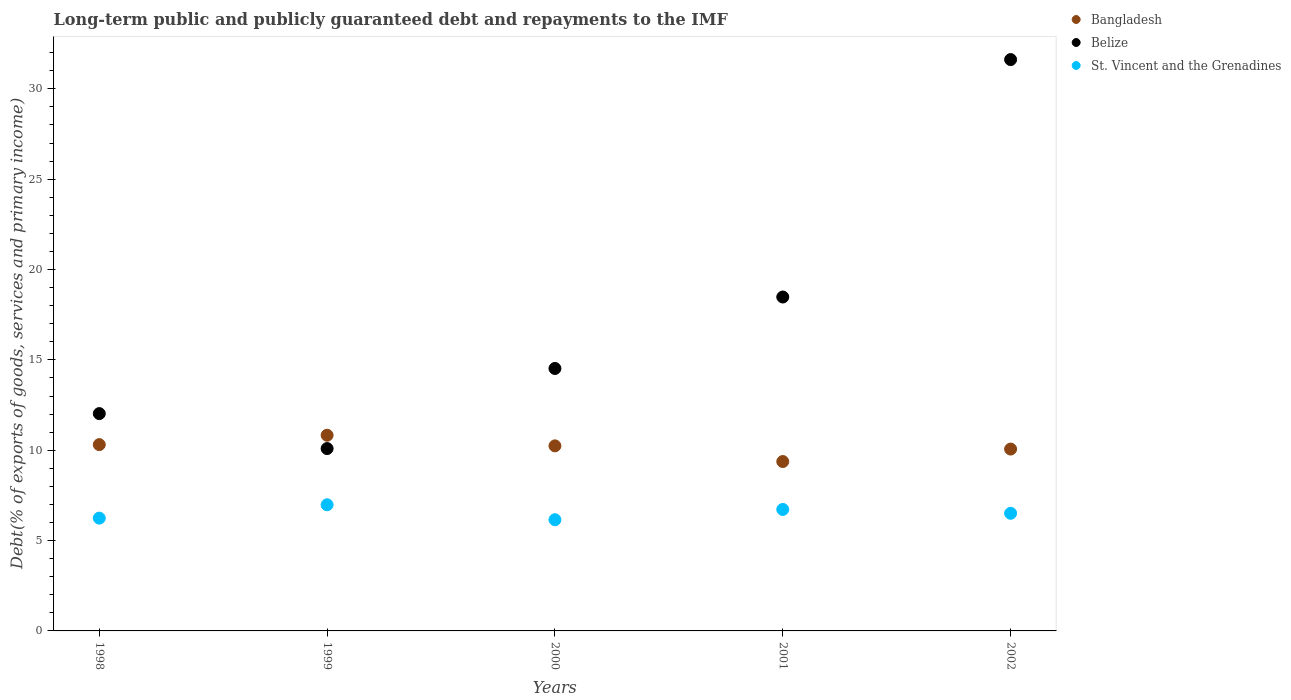Is the number of dotlines equal to the number of legend labels?
Offer a very short reply. Yes. What is the debt and repayments in Belize in 2001?
Provide a succinct answer. 18.48. Across all years, what is the maximum debt and repayments in Bangladesh?
Make the answer very short. 10.83. Across all years, what is the minimum debt and repayments in Belize?
Keep it short and to the point. 10.09. In which year was the debt and repayments in St. Vincent and the Grenadines maximum?
Keep it short and to the point. 1999. What is the total debt and repayments in Belize in the graph?
Offer a very short reply. 86.74. What is the difference between the debt and repayments in St. Vincent and the Grenadines in 1998 and that in 2001?
Offer a very short reply. -0.48. What is the difference between the debt and repayments in Belize in 1998 and the debt and repayments in St. Vincent and the Grenadines in 2000?
Offer a terse response. 5.87. What is the average debt and repayments in Bangladesh per year?
Provide a succinct answer. 10.16. In the year 2002, what is the difference between the debt and repayments in Belize and debt and repayments in Bangladesh?
Provide a succinct answer. 21.56. In how many years, is the debt and repayments in Bangladesh greater than 23 %?
Offer a very short reply. 0. What is the ratio of the debt and repayments in Bangladesh in 1998 to that in 1999?
Your response must be concise. 0.95. Is the debt and repayments in St. Vincent and the Grenadines in 1998 less than that in 1999?
Provide a succinct answer. Yes. Is the difference between the debt and repayments in Belize in 2000 and 2002 greater than the difference between the debt and repayments in Bangladesh in 2000 and 2002?
Offer a very short reply. No. What is the difference between the highest and the second highest debt and repayments in Belize?
Provide a short and direct response. 13.14. What is the difference between the highest and the lowest debt and repayments in Bangladesh?
Make the answer very short. 1.46. Is it the case that in every year, the sum of the debt and repayments in Belize and debt and repayments in St. Vincent and the Grenadines  is greater than the debt and repayments in Bangladesh?
Offer a terse response. Yes. What is the difference between two consecutive major ticks on the Y-axis?
Provide a short and direct response. 5. Are the values on the major ticks of Y-axis written in scientific E-notation?
Offer a very short reply. No. Does the graph contain grids?
Give a very brief answer. No. Where does the legend appear in the graph?
Your response must be concise. Top right. How many legend labels are there?
Your response must be concise. 3. How are the legend labels stacked?
Keep it short and to the point. Vertical. What is the title of the graph?
Make the answer very short. Long-term public and publicly guaranteed debt and repayments to the IMF. Does "Belgium" appear as one of the legend labels in the graph?
Offer a very short reply. No. What is the label or title of the X-axis?
Make the answer very short. Years. What is the label or title of the Y-axis?
Ensure brevity in your answer.  Debt(% of exports of goods, services and primary income). What is the Debt(% of exports of goods, services and primary income) of Bangladesh in 1998?
Your answer should be compact. 10.31. What is the Debt(% of exports of goods, services and primary income) of Belize in 1998?
Offer a terse response. 12.03. What is the Debt(% of exports of goods, services and primary income) of St. Vincent and the Grenadines in 1998?
Your response must be concise. 6.24. What is the Debt(% of exports of goods, services and primary income) of Bangladesh in 1999?
Ensure brevity in your answer.  10.83. What is the Debt(% of exports of goods, services and primary income) in Belize in 1999?
Your answer should be very brief. 10.09. What is the Debt(% of exports of goods, services and primary income) in St. Vincent and the Grenadines in 1999?
Your answer should be very brief. 6.98. What is the Debt(% of exports of goods, services and primary income) in Bangladesh in 2000?
Your answer should be very brief. 10.24. What is the Debt(% of exports of goods, services and primary income) in Belize in 2000?
Your response must be concise. 14.52. What is the Debt(% of exports of goods, services and primary income) in St. Vincent and the Grenadines in 2000?
Your response must be concise. 6.15. What is the Debt(% of exports of goods, services and primary income) in Bangladesh in 2001?
Offer a terse response. 9.37. What is the Debt(% of exports of goods, services and primary income) of Belize in 2001?
Make the answer very short. 18.48. What is the Debt(% of exports of goods, services and primary income) in St. Vincent and the Grenadines in 2001?
Offer a terse response. 6.72. What is the Debt(% of exports of goods, services and primary income) of Bangladesh in 2002?
Your response must be concise. 10.06. What is the Debt(% of exports of goods, services and primary income) of Belize in 2002?
Ensure brevity in your answer.  31.62. What is the Debt(% of exports of goods, services and primary income) of St. Vincent and the Grenadines in 2002?
Provide a short and direct response. 6.51. Across all years, what is the maximum Debt(% of exports of goods, services and primary income) of Bangladesh?
Provide a succinct answer. 10.83. Across all years, what is the maximum Debt(% of exports of goods, services and primary income) in Belize?
Make the answer very short. 31.62. Across all years, what is the maximum Debt(% of exports of goods, services and primary income) in St. Vincent and the Grenadines?
Provide a short and direct response. 6.98. Across all years, what is the minimum Debt(% of exports of goods, services and primary income) of Bangladesh?
Make the answer very short. 9.37. Across all years, what is the minimum Debt(% of exports of goods, services and primary income) in Belize?
Your answer should be very brief. 10.09. Across all years, what is the minimum Debt(% of exports of goods, services and primary income) in St. Vincent and the Grenadines?
Provide a succinct answer. 6.15. What is the total Debt(% of exports of goods, services and primary income) of Bangladesh in the graph?
Your answer should be very brief. 50.82. What is the total Debt(% of exports of goods, services and primary income) of Belize in the graph?
Your response must be concise. 86.74. What is the total Debt(% of exports of goods, services and primary income) in St. Vincent and the Grenadines in the graph?
Offer a terse response. 32.61. What is the difference between the Debt(% of exports of goods, services and primary income) in Bangladesh in 1998 and that in 1999?
Your answer should be very brief. -0.52. What is the difference between the Debt(% of exports of goods, services and primary income) of Belize in 1998 and that in 1999?
Offer a terse response. 1.94. What is the difference between the Debt(% of exports of goods, services and primary income) of St. Vincent and the Grenadines in 1998 and that in 1999?
Offer a very short reply. -0.74. What is the difference between the Debt(% of exports of goods, services and primary income) in Bangladesh in 1998 and that in 2000?
Your response must be concise. 0.07. What is the difference between the Debt(% of exports of goods, services and primary income) of Belize in 1998 and that in 2000?
Your answer should be very brief. -2.5. What is the difference between the Debt(% of exports of goods, services and primary income) of St. Vincent and the Grenadines in 1998 and that in 2000?
Your answer should be very brief. 0.09. What is the difference between the Debt(% of exports of goods, services and primary income) of Bangladesh in 1998 and that in 2001?
Make the answer very short. 0.94. What is the difference between the Debt(% of exports of goods, services and primary income) in Belize in 1998 and that in 2001?
Offer a terse response. -6.45. What is the difference between the Debt(% of exports of goods, services and primary income) of St. Vincent and the Grenadines in 1998 and that in 2001?
Keep it short and to the point. -0.48. What is the difference between the Debt(% of exports of goods, services and primary income) in Bangladesh in 1998 and that in 2002?
Ensure brevity in your answer.  0.25. What is the difference between the Debt(% of exports of goods, services and primary income) in Belize in 1998 and that in 2002?
Your answer should be very brief. -19.59. What is the difference between the Debt(% of exports of goods, services and primary income) in St. Vincent and the Grenadines in 1998 and that in 2002?
Provide a succinct answer. -0.27. What is the difference between the Debt(% of exports of goods, services and primary income) of Bangladesh in 1999 and that in 2000?
Offer a very short reply. 0.59. What is the difference between the Debt(% of exports of goods, services and primary income) in Belize in 1999 and that in 2000?
Make the answer very short. -4.43. What is the difference between the Debt(% of exports of goods, services and primary income) of St. Vincent and the Grenadines in 1999 and that in 2000?
Your answer should be very brief. 0.83. What is the difference between the Debt(% of exports of goods, services and primary income) in Bangladesh in 1999 and that in 2001?
Offer a terse response. 1.46. What is the difference between the Debt(% of exports of goods, services and primary income) in Belize in 1999 and that in 2001?
Provide a short and direct response. -8.39. What is the difference between the Debt(% of exports of goods, services and primary income) of St. Vincent and the Grenadines in 1999 and that in 2001?
Your answer should be compact. 0.26. What is the difference between the Debt(% of exports of goods, services and primary income) in Bangladesh in 1999 and that in 2002?
Your answer should be very brief. 0.77. What is the difference between the Debt(% of exports of goods, services and primary income) of Belize in 1999 and that in 2002?
Give a very brief answer. -21.53. What is the difference between the Debt(% of exports of goods, services and primary income) of St. Vincent and the Grenadines in 1999 and that in 2002?
Give a very brief answer. 0.47. What is the difference between the Debt(% of exports of goods, services and primary income) in Bangladesh in 2000 and that in 2001?
Offer a terse response. 0.87. What is the difference between the Debt(% of exports of goods, services and primary income) in Belize in 2000 and that in 2001?
Offer a very short reply. -3.95. What is the difference between the Debt(% of exports of goods, services and primary income) in St. Vincent and the Grenadines in 2000 and that in 2001?
Offer a terse response. -0.57. What is the difference between the Debt(% of exports of goods, services and primary income) of Bangladesh in 2000 and that in 2002?
Give a very brief answer. 0.18. What is the difference between the Debt(% of exports of goods, services and primary income) of Belize in 2000 and that in 2002?
Ensure brevity in your answer.  -17.09. What is the difference between the Debt(% of exports of goods, services and primary income) in St. Vincent and the Grenadines in 2000 and that in 2002?
Give a very brief answer. -0.36. What is the difference between the Debt(% of exports of goods, services and primary income) of Bangladesh in 2001 and that in 2002?
Make the answer very short. -0.69. What is the difference between the Debt(% of exports of goods, services and primary income) in Belize in 2001 and that in 2002?
Keep it short and to the point. -13.14. What is the difference between the Debt(% of exports of goods, services and primary income) of St. Vincent and the Grenadines in 2001 and that in 2002?
Your response must be concise. 0.21. What is the difference between the Debt(% of exports of goods, services and primary income) in Bangladesh in 1998 and the Debt(% of exports of goods, services and primary income) in Belize in 1999?
Offer a very short reply. 0.22. What is the difference between the Debt(% of exports of goods, services and primary income) in Bangladesh in 1998 and the Debt(% of exports of goods, services and primary income) in St. Vincent and the Grenadines in 1999?
Ensure brevity in your answer.  3.33. What is the difference between the Debt(% of exports of goods, services and primary income) in Belize in 1998 and the Debt(% of exports of goods, services and primary income) in St. Vincent and the Grenadines in 1999?
Your answer should be very brief. 5.05. What is the difference between the Debt(% of exports of goods, services and primary income) of Bangladesh in 1998 and the Debt(% of exports of goods, services and primary income) of Belize in 2000?
Offer a terse response. -4.21. What is the difference between the Debt(% of exports of goods, services and primary income) in Bangladesh in 1998 and the Debt(% of exports of goods, services and primary income) in St. Vincent and the Grenadines in 2000?
Ensure brevity in your answer.  4.16. What is the difference between the Debt(% of exports of goods, services and primary income) in Belize in 1998 and the Debt(% of exports of goods, services and primary income) in St. Vincent and the Grenadines in 2000?
Your answer should be compact. 5.87. What is the difference between the Debt(% of exports of goods, services and primary income) in Bangladesh in 1998 and the Debt(% of exports of goods, services and primary income) in Belize in 2001?
Offer a very short reply. -8.17. What is the difference between the Debt(% of exports of goods, services and primary income) in Bangladesh in 1998 and the Debt(% of exports of goods, services and primary income) in St. Vincent and the Grenadines in 2001?
Offer a very short reply. 3.59. What is the difference between the Debt(% of exports of goods, services and primary income) of Belize in 1998 and the Debt(% of exports of goods, services and primary income) of St. Vincent and the Grenadines in 2001?
Your answer should be compact. 5.3. What is the difference between the Debt(% of exports of goods, services and primary income) in Bangladesh in 1998 and the Debt(% of exports of goods, services and primary income) in Belize in 2002?
Provide a succinct answer. -21.31. What is the difference between the Debt(% of exports of goods, services and primary income) of Bangladesh in 1998 and the Debt(% of exports of goods, services and primary income) of St. Vincent and the Grenadines in 2002?
Your answer should be compact. 3.8. What is the difference between the Debt(% of exports of goods, services and primary income) of Belize in 1998 and the Debt(% of exports of goods, services and primary income) of St. Vincent and the Grenadines in 2002?
Make the answer very short. 5.52. What is the difference between the Debt(% of exports of goods, services and primary income) in Bangladesh in 1999 and the Debt(% of exports of goods, services and primary income) in Belize in 2000?
Offer a terse response. -3.69. What is the difference between the Debt(% of exports of goods, services and primary income) of Bangladesh in 1999 and the Debt(% of exports of goods, services and primary income) of St. Vincent and the Grenadines in 2000?
Your answer should be compact. 4.68. What is the difference between the Debt(% of exports of goods, services and primary income) in Belize in 1999 and the Debt(% of exports of goods, services and primary income) in St. Vincent and the Grenadines in 2000?
Your answer should be very brief. 3.94. What is the difference between the Debt(% of exports of goods, services and primary income) in Bangladesh in 1999 and the Debt(% of exports of goods, services and primary income) in Belize in 2001?
Ensure brevity in your answer.  -7.65. What is the difference between the Debt(% of exports of goods, services and primary income) of Bangladesh in 1999 and the Debt(% of exports of goods, services and primary income) of St. Vincent and the Grenadines in 2001?
Ensure brevity in your answer.  4.11. What is the difference between the Debt(% of exports of goods, services and primary income) of Belize in 1999 and the Debt(% of exports of goods, services and primary income) of St. Vincent and the Grenadines in 2001?
Provide a short and direct response. 3.37. What is the difference between the Debt(% of exports of goods, services and primary income) in Bangladesh in 1999 and the Debt(% of exports of goods, services and primary income) in Belize in 2002?
Give a very brief answer. -20.79. What is the difference between the Debt(% of exports of goods, services and primary income) of Bangladesh in 1999 and the Debt(% of exports of goods, services and primary income) of St. Vincent and the Grenadines in 2002?
Make the answer very short. 4.32. What is the difference between the Debt(% of exports of goods, services and primary income) of Belize in 1999 and the Debt(% of exports of goods, services and primary income) of St. Vincent and the Grenadines in 2002?
Your answer should be very brief. 3.58. What is the difference between the Debt(% of exports of goods, services and primary income) of Bangladesh in 2000 and the Debt(% of exports of goods, services and primary income) of Belize in 2001?
Offer a terse response. -8.24. What is the difference between the Debt(% of exports of goods, services and primary income) of Bangladesh in 2000 and the Debt(% of exports of goods, services and primary income) of St. Vincent and the Grenadines in 2001?
Provide a short and direct response. 3.52. What is the difference between the Debt(% of exports of goods, services and primary income) in Belize in 2000 and the Debt(% of exports of goods, services and primary income) in St. Vincent and the Grenadines in 2001?
Your answer should be very brief. 7.8. What is the difference between the Debt(% of exports of goods, services and primary income) of Bangladesh in 2000 and the Debt(% of exports of goods, services and primary income) of Belize in 2002?
Your answer should be very brief. -21.38. What is the difference between the Debt(% of exports of goods, services and primary income) of Bangladesh in 2000 and the Debt(% of exports of goods, services and primary income) of St. Vincent and the Grenadines in 2002?
Keep it short and to the point. 3.73. What is the difference between the Debt(% of exports of goods, services and primary income) of Belize in 2000 and the Debt(% of exports of goods, services and primary income) of St. Vincent and the Grenadines in 2002?
Your answer should be very brief. 8.01. What is the difference between the Debt(% of exports of goods, services and primary income) of Bangladesh in 2001 and the Debt(% of exports of goods, services and primary income) of Belize in 2002?
Your answer should be very brief. -22.25. What is the difference between the Debt(% of exports of goods, services and primary income) of Bangladesh in 2001 and the Debt(% of exports of goods, services and primary income) of St. Vincent and the Grenadines in 2002?
Make the answer very short. 2.86. What is the difference between the Debt(% of exports of goods, services and primary income) in Belize in 2001 and the Debt(% of exports of goods, services and primary income) in St. Vincent and the Grenadines in 2002?
Give a very brief answer. 11.97. What is the average Debt(% of exports of goods, services and primary income) of Bangladesh per year?
Provide a short and direct response. 10.16. What is the average Debt(% of exports of goods, services and primary income) in Belize per year?
Ensure brevity in your answer.  17.35. What is the average Debt(% of exports of goods, services and primary income) of St. Vincent and the Grenadines per year?
Offer a terse response. 6.52. In the year 1998, what is the difference between the Debt(% of exports of goods, services and primary income) in Bangladesh and Debt(% of exports of goods, services and primary income) in Belize?
Offer a very short reply. -1.72. In the year 1998, what is the difference between the Debt(% of exports of goods, services and primary income) in Bangladesh and Debt(% of exports of goods, services and primary income) in St. Vincent and the Grenadines?
Ensure brevity in your answer.  4.07. In the year 1998, what is the difference between the Debt(% of exports of goods, services and primary income) in Belize and Debt(% of exports of goods, services and primary income) in St. Vincent and the Grenadines?
Ensure brevity in your answer.  5.79. In the year 1999, what is the difference between the Debt(% of exports of goods, services and primary income) in Bangladesh and Debt(% of exports of goods, services and primary income) in Belize?
Ensure brevity in your answer.  0.74. In the year 1999, what is the difference between the Debt(% of exports of goods, services and primary income) in Bangladesh and Debt(% of exports of goods, services and primary income) in St. Vincent and the Grenadines?
Keep it short and to the point. 3.85. In the year 1999, what is the difference between the Debt(% of exports of goods, services and primary income) of Belize and Debt(% of exports of goods, services and primary income) of St. Vincent and the Grenadines?
Offer a very short reply. 3.11. In the year 2000, what is the difference between the Debt(% of exports of goods, services and primary income) in Bangladesh and Debt(% of exports of goods, services and primary income) in Belize?
Provide a succinct answer. -4.28. In the year 2000, what is the difference between the Debt(% of exports of goods, services and primary income) in Bangladesh and Debt(% of exports of goods, services and primary income) in St. Vincent and the Grenadines?
Make the answer very short. 4.09. In the year 2000, what is the difference between the Debt(% of exports of goods, services and primary income) of Belize and Debt(% of exports of goods, services and primary income) of St. Vincent and the Grenadines?
Your answer should be very brief. 8.37. In the year 2001, what is the difference between the Debt(% of exports of goods, services and primary income) in Bangladesh and Debt(% of exports of goods, services and primary income) in Belize?
Your answer should be very brief. -9.11. In the year 2001, what is the difference between the Debt(% of exports of goods, services and primary income) in Bangladesh and Debt(% of exports of goods, services and primary income) in St. Vincent and the Grenadines?
Your response must be concise. 2.65. In the year 2001, what is the difference between the Debt(% of exports of goods, services and primary income) of Belize and Debt(% of exports of goods, services and primary income) of St. Vincent and the Grenadines?
Keep it short and to the point. 11.76. In the year 2002, what is the difference between the Debt(% of exports of goods, services and primary income) of Bangladesh and Debt(% of exports of goods, services and primary income) of Belize?
Make the answer very short. -21.56. In the year 2002, what is the difference between the Debt(% of exports of goods, services and primary income) of Bangladesh and Debt(% of exports of goods, services and primary income) of St. Vincent and the Grenadines?
Give a very brief answer. 3.55. In the year 2002, what is the difference between the Debt(% of exports of goods, services and primary income) of Belize and Debt(% of exports of goods, services and primary income) of St. Vincent and the Grenadines?
Give a very brief answer. 25.11. What is the ratio of the Debt(% of exports of goods, services and primary income) of Bangladesh in 1998 to that in 1999?
Provide a succinct answer. 0.95. What is the ratio of the Debt(% of exports of goods, services and primary income) of Belize in 1998 to that in 1999?
Provide a short and direct response. 1.19. What is the ratio of the Debt(% of exports of goods, services and primary income) in St. Vincent and the Grenadines in 1998 to that in 1999?
Make the answer very short. 0.89. What is the ratio of the Debt(% of exports of goods, services and primary income) of Bangladesh in 1998 to that in 2000?
Offer a terse response. 1.01. What is the ratio of the Debt(% of exports of goods, services and primary income) in Belize in 1998 to that in 2000?
Provide a short and direct response. 0.83. What is the ratio of the Debt(% of exports of goods, services and primary income) of St. Vincent and the Grenadines in 1998 to that in 2000?
Your answer should be very brief. 1.01. What is the ratio of the Debt(% of exports of goods, services and primary income) of Bangladesh in 1998 to that in 2001?
Provide a succinct answer. 1.1. What is the ratio of the Debt(% of exports of goods, services and primary income) in Belize in 1998 to that in 2001?
Your answer should be compact. 0.65. What is the ratio of the Debt(% of exports of goods, services and primary income) in St. Vincent and the Grenadines in 1998 to that in 2001?
Make the answer very short. 0.93. What is the ratio of the Debt(% of exports of goods, services and primary income) in Bangladesh in 1998 to that in 2002?
Offer a very short reply. 1.02. What is the ratio of the Debt(% of exports of goods, services and primary income) of Belize in 1998 to that in 2002?
Your answer should be compact. 0.38. What is the ratio of the Debt(% of exports of goods, services and primary income) in St. Vincent and the Grenadines in 1998 to that in 2002?
Provide a succinct answer. 0.96. What is the ratio of the Debt(% of exports of goods, services and primary income) in Bangladesh in 1999 to that in 2000?
Provide a succinct answer. 1.06. What is the ratio of the Debt(% of exports of goods, services and primary income) of Belize in 1999 to that in 2000?
Your response must be concise. 0.69. What is the ratio of the Debt(% of exports of goods, services and primary income) in St. Vincent and the Grenadines in 1999 to that in 2000?
Provide a succinct answer. 1.13. What is the ratio of the Debt(% of exports of goods, services and primary income) of Bangladesh in 1999 to that in 2001?
Your response must be concise. 1.16. What is the ratio of the Debt(% of exports of goods, services and primary income) of Belize in 1999 to that in 2001?
Your answer should be compact. 0.55. What is the ratio of the Debt(% of exports of goods, services and primary income) of St. Vincent and the Grenadines in 1999 to that in 2001?
Your answer should be compact. 1.04. What is the ratio of the Debt(% of exports of goods, services and primary income) of Bangladesh in 1999 to that in 2002?
Your response must be concise. 1.08. What is the ratio of the Debt(% of exports of goods, services and primary income) in Belize in 1999 to that in 2002?
Your answer should be very brief. 0.32. What is the ratio of the Debt(% of exports of goods, services and primary income) in St. Vincent and the Grenadines in 1999 to that in 2002?
Your response must be concise. 1.07. What is the ratio of the Debt(% of exports of goods, services and primary income) of Bangladesh in 2000 to that in 2001?
Offer a terse response. 1.09. What is the ratio of the Debt(% of exports of goods, services and primary income) of Belize in 2000 to that in 2001?
Your response must be concise. 0.79. What is the ratio of the Debt(% of exports of goods, services and primary income) of St. Vincent and the Grenadines in 2000 to that in 2001?
Provide a short and direct response. 0.92. What is the ratio of the Debt(% of exports of goods, services and primary income) in Bangladesh in 2000 to that in 2002?
Provide a short and direct response. 1.02. What is the ratio of the Debt(% of exports of goods, services and primary income) of Belize in 2000 to that in 2002?
Give a very brief answer. 0.46. What is the ratio of the Debt(% of exports of goods, services and primary income) in St. Vincent and the Grenadines in 2000 to that in 2002?
Provide a succinct answer. 0.95. What is the ratio of the Debt(% of exports of goods, services and primary income) of Bangladesh in 2001 to that in 2002?
Keep it short and to the point. 0.93. What is the ratio of the Debt(% of exports of goods, services and primary income) of Belize in 2001 to that in 2002?
Your answer should be compact. 0.58. What is the ratio of the Debt(% of exports of goods, services and primary income) of St. Vincent and the Grenadines in 2001 to that in 2002?
Your response must be concise. 1.03. What is the difference between the highest and the second highest Debt(% of exports of goods, services and primary income) in Bangladesh?
Give a very brief answer. 0.52. What is the difference between the highest and the second highest Debt(% of exports of goods, services and primary income) in Belize?
Offer a very short reply. 13.14. What is the difference between the highest and the second highest Debt(% of exports of goods, services and primary income) in St. Vincent and the Grenadines?
Offer a terse response. 0.26. What is the difference between the highest and the lowest Debt(% of exports of goods, services and primary income) of Bangladesh?
Provide a short and direct response. 1.46. What is the difference between the highest and the lowest Debt(% of exports of goods, services and primary income) of Belize?
Offer a terse response. 21.53. What is the difference between the highest and the lowest Debt(% of exports of goods, services and primary income) of St. Vincent and the Grenadines?
Keep it short and to the point. 0.83. 